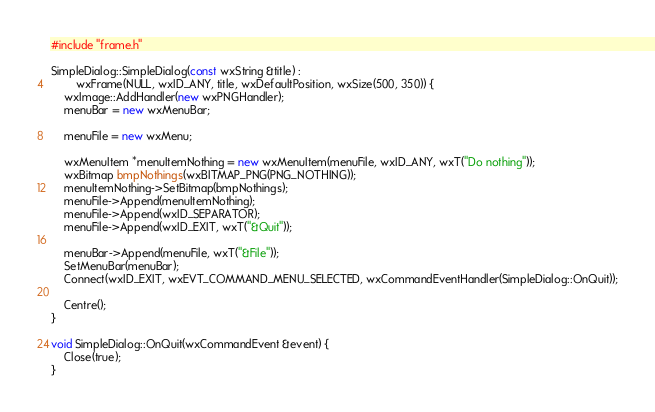<code> <loc_0><loc_0><loc_500><loc_500><_C++_>#include "frame.h"

SimpleDialog::SimpleDialog(const wxString &title) :
        wxFrame(NULL, wxID_ANY, title, wxDefaultPosition, wxSize(500, 350)) {
    wxImage::AddHandler(new wxPNGHandler);
    menuBar = new wxMenuBar;

    menuFile = new wxMenu;

    wxMenuItem *menuItemNothing = new wxMenuItem(menuFile, wxID_ANY, wxT("Do nothing"));
    wxBitmap bmpNothings(wxBITMAP_PNG(PNG_NOTHING));
    menuItemNothing->SetBitmap(bmpNothings);
    menuFile->Append(menuItemNothing);
    menuFile->Append(wxID_SEPARATOR);
    menuFile->Append(wxID_EXIT, wxT("&Quit"));

    menuBar->Append(menuFile, wxT("&File"));
    SetMenuBar(menuBar);
    Connect(wxID_EXIT, wxEVT_COMMAND_MENU_SELECTED, wxCommandEventHandler(SimpleDialog::OnQuit));

    Centre();
}

void SimpleDialog::OnQuit(wxCommandEvent &event) {
    Close(true);
}</code> 